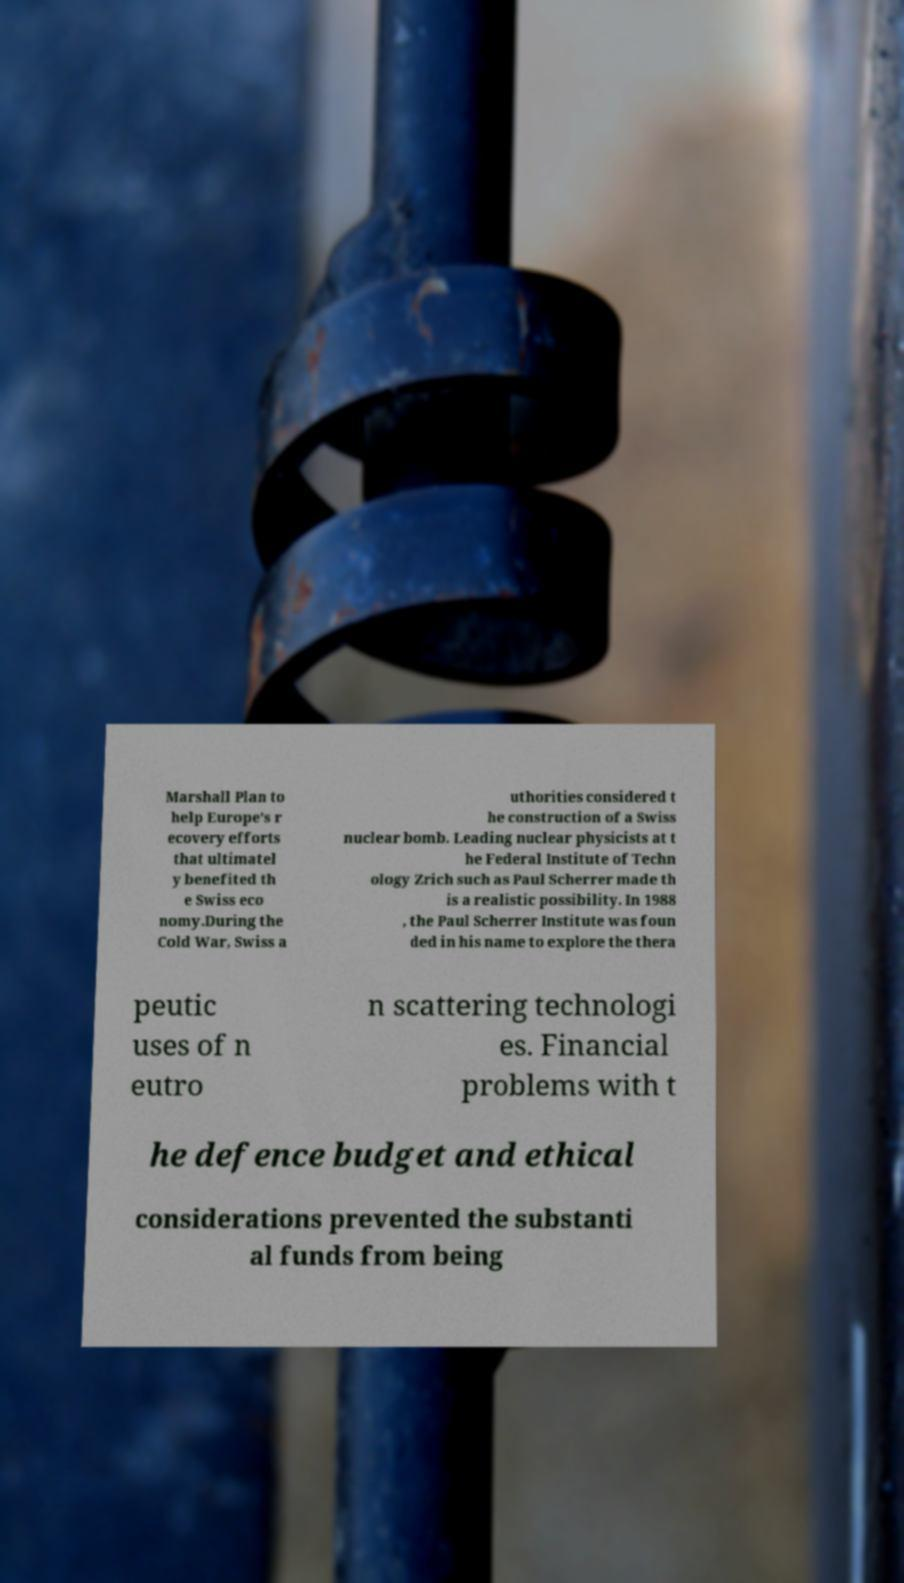I need the written content from this picture converted into text. Can you do that? Marshall Plan to help Europe's r ecovery efforts that ultimatel y benefited th e Swiss eco nomy.During the Cold War, Swiss a uthorities considered t he construction of a Swiss nuclear bomb. Leading nuclear physicists at t he Federal Institute of Techn ology Zrich such as Paul Scherrer made th is a realistic possibility. In 1988 , the Paul Scherrer Institute was foun ded in his name to explore the thera peutic uses of n eutro n scattering technologi es. Financial problems with t he defence budget and ethical considerations prevented the substanti al funds from being 